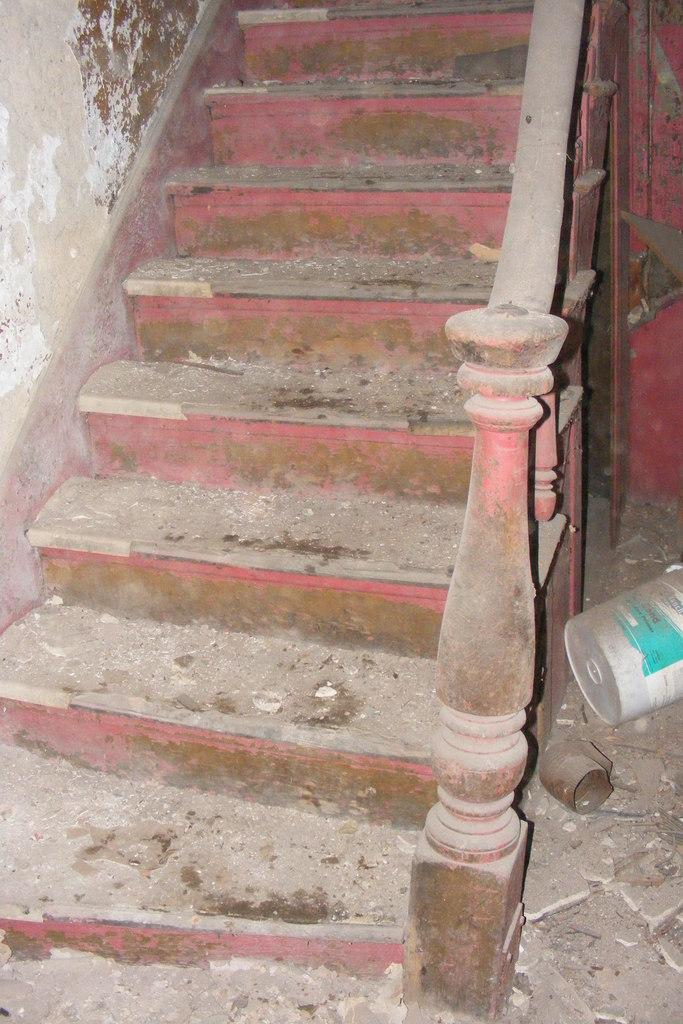What type of structure is present on the left side of the image? There is a wall on the left side of the image. What can be seen on the right side of the image? There is a bucket on the right side of the image. What feature is present alongside the staircase in the image? There is a staircase railing in the image. What is the main architectural element in the image? The main architectural element in the image is the staircase. How many brothers are depicted in the image? There are no brothers present in the image; it features a staircase, a railing, a wall, and a bucket. 